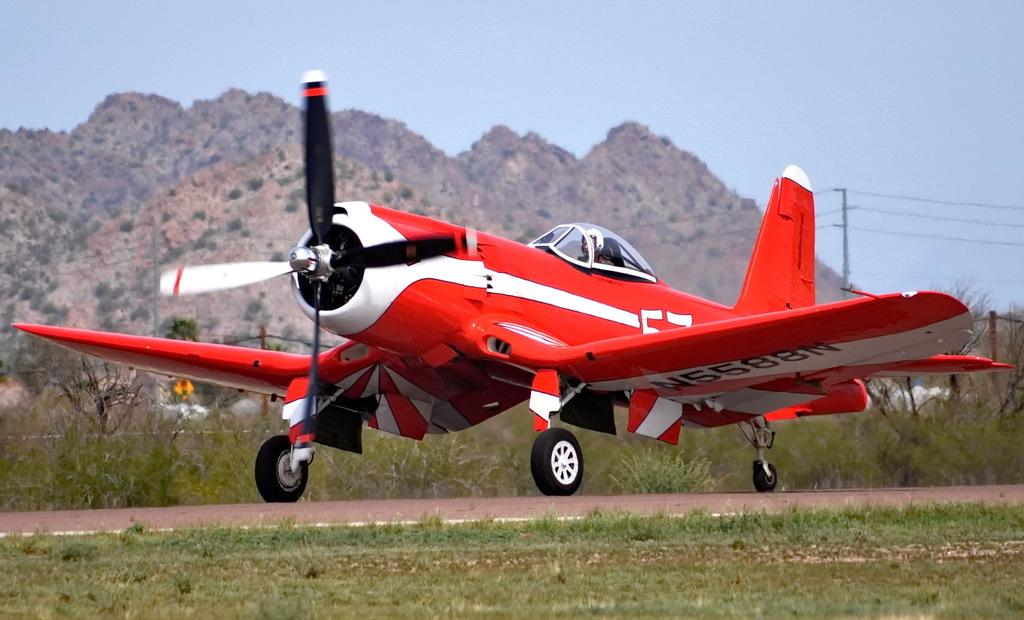<image>
Present a compact description of the photo's key features. The wing of  propeller plane contains the ID number N5588N on its underside. 